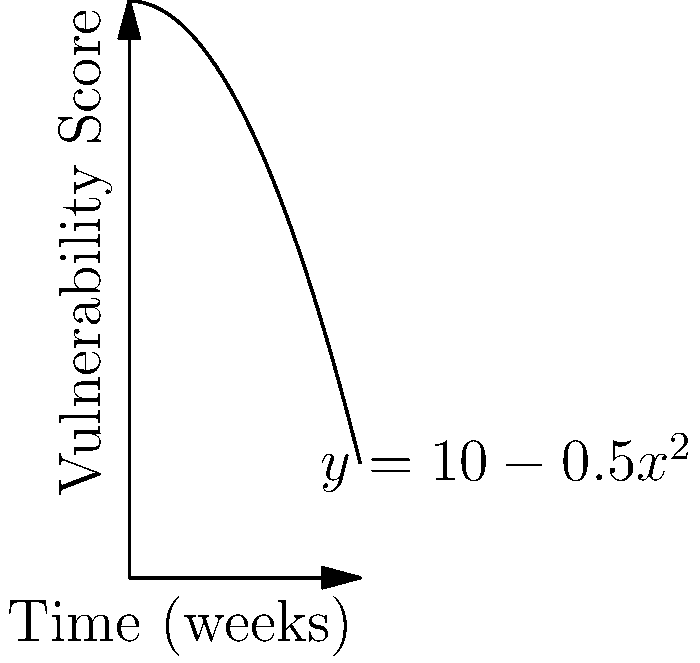Given the vulnerability score function $y = 10 - 0.5x^2$, where $y$ represents the system vulnerability score and $x$ represents time in weeks, calculate the total vulnerability exposure over a 4-week period. Round your answer to two decimal places. To calculate the total vulnerability exposure, we need to find the area under the curve from $x=0$ to $x=4$. This can be done using definite integration:

1) Set up the integral:
   $$\int_0^4 (10 - 0.5x^2) dx$$

2) Integrate the function:
   $$\left[10x - \frac{1}{6}x^3\right]_0^4$$

3) Evaluate the integral:
   $$\left(40 - \frac{64}{6}\right) - \left(0 - 0\right) = 40 - \frac{32}{3}$$

4) Simplify:
   $$40 - \frac{32}{3} = \frac{120}{3} - \frac{32}{3} = \frac{88}{3} \approx 29.33$$

5) Round to two decimal places: 29.33

This value represents the total vulnerability exposure over the 4-week period.
Answer: 29.33 